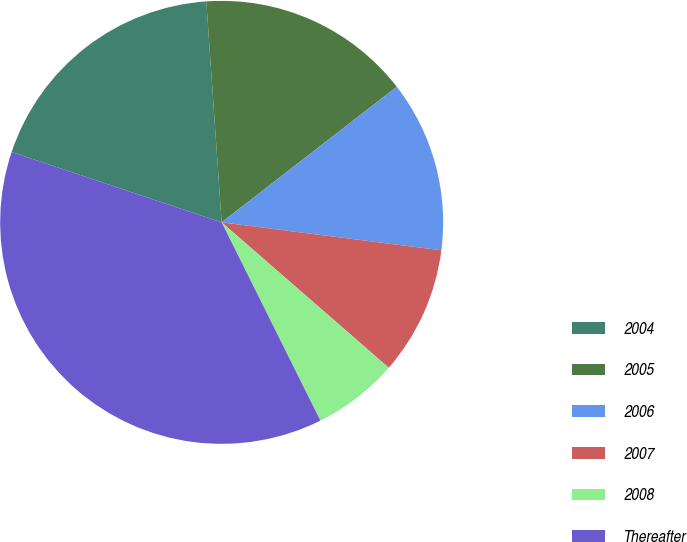Convert chart. <chart><loc_0><loc_0><loc_500><loc_500><pie_chart><fcel>2004<fcel>2005<fcel>2006<fcel>2007<fcel>2008<fcel>Thereafter<nl><fcel>18.75%<fcel>15.62%<fcel>12.5%<fcel>9.38%<fcel>6.25%<fcel>37.5%<nl></chart> 